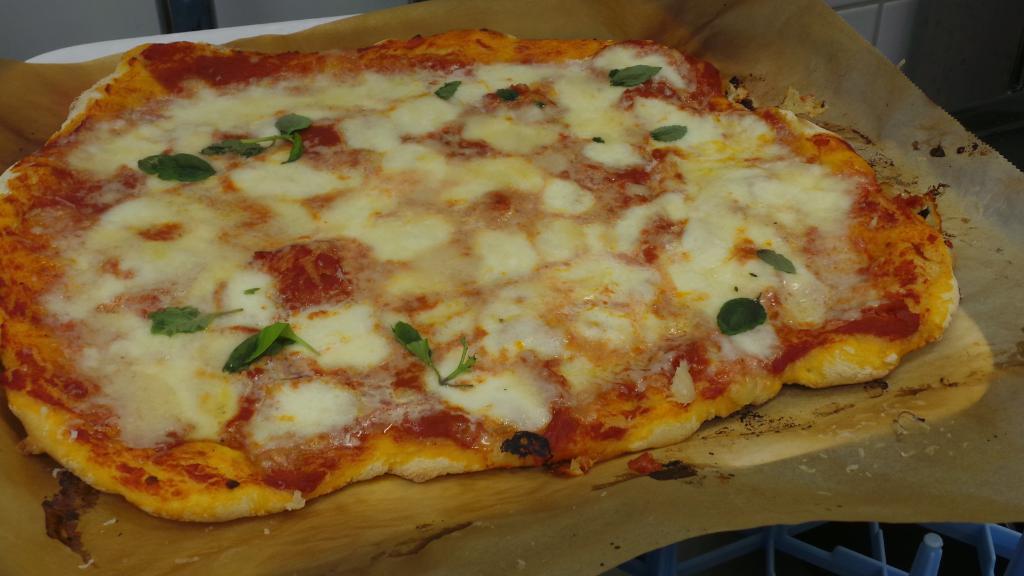How would you summarize this image in a sentence or two? In this picture we can see a wooden chopping board at the bottom, there is a pizza present on the chopping board, we can see a dark background. 